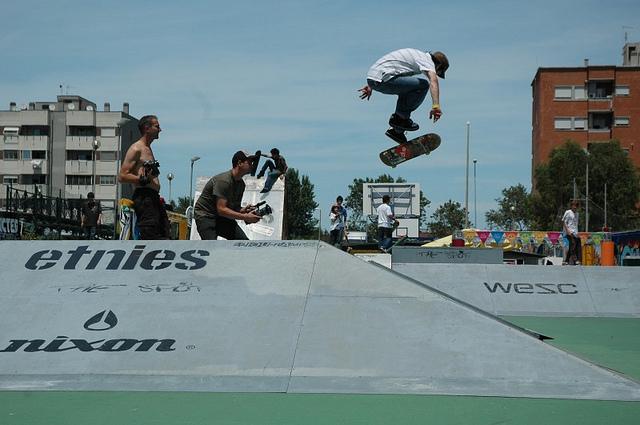Is there an audience?
Keep it brief. No. What is written on the ramp in the foreground?
Short answer required. Etnies nixon. How many buildings are in the picture?
Concise answer only. 3. Is the man hitting something?
Answer briefly. No. What shoe company sponsored this?
Concise answer only. Etnies. Is this a competition?
Be succinct. Yes. What sport is this?
Write a very short answer. Skateboarding. What is the object on the left side of the photo?
Give a very brief answer. Ramp. Is he going to nail the landing?
Concise answer only. Yes. What audio brand is advertised under the skater?
Quick response, please. Nixon. What does it say in black lettering?
Quick response, please. Etnies nixon. Is this a construction site?
Write a very short answer. No. Who is recording the skateboarder?
Write a very short answer. Friend. Was the picture taken in an office?
Be succinct. No. How many players are there?
Write a very short answer. 1. Is the high in the air?
Write a very short answer. Yes. 